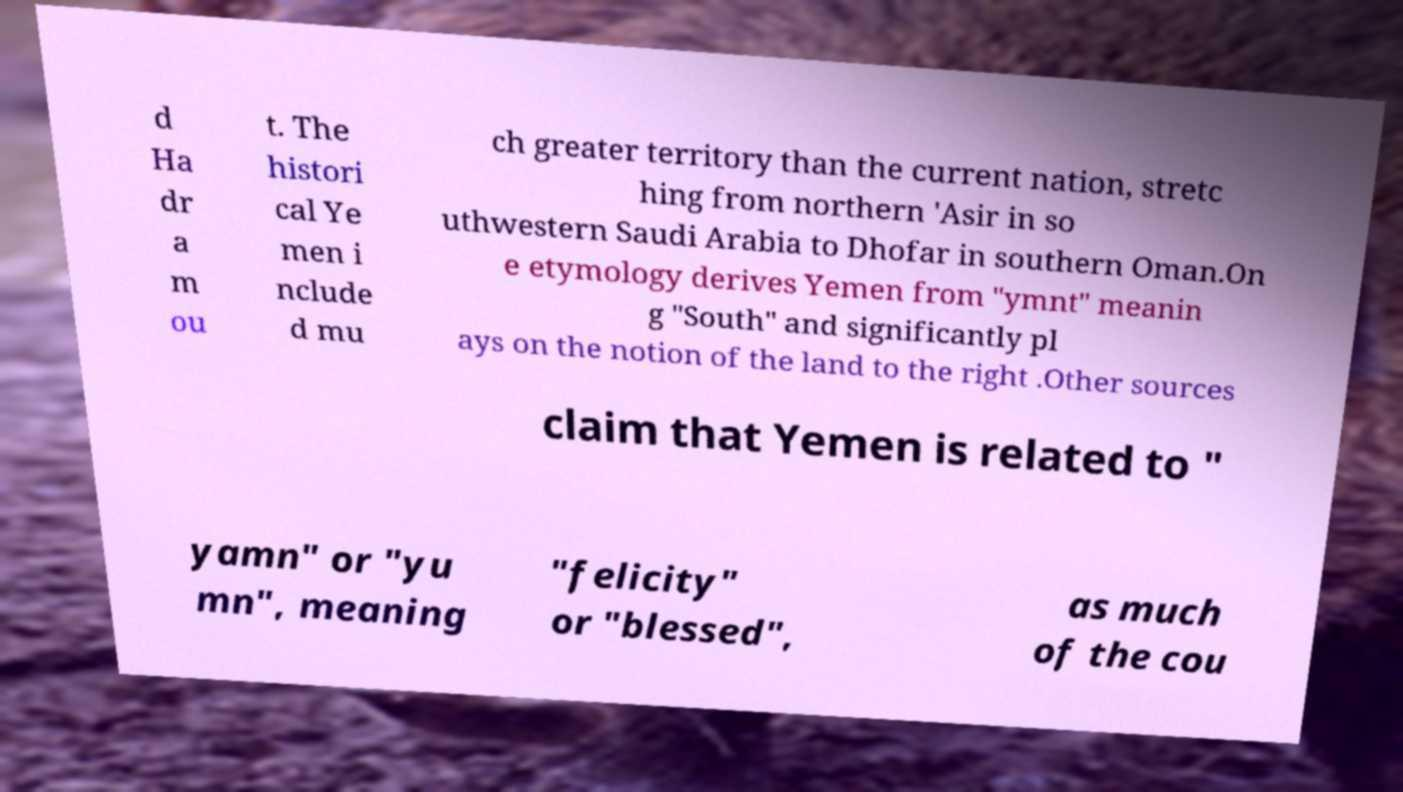Can you accurately transcribe the text from the provided image for me? d Ha dr a m ou t. The histori cal Ye men i nclude d mu ch greater territory than the current nation, stretc hing from northern 'Asir in so uthwestern Saudi Arabia to Dhofar in southern Oman.On e etymology derives Yemen from "ymnt" meanin g "South" and significantly pl ays on the notion of the land to the right .Other sources claim that Yemen is related to " yamn" or "yu mn", meaning "felicity" or "blessed", as much of the cou 